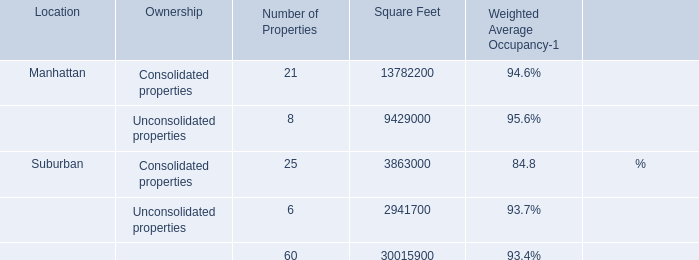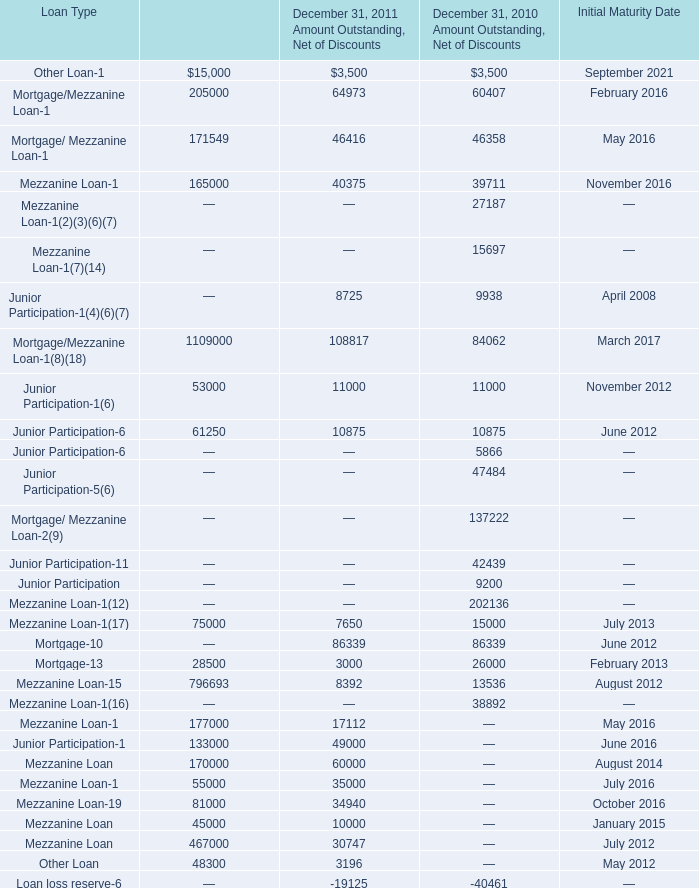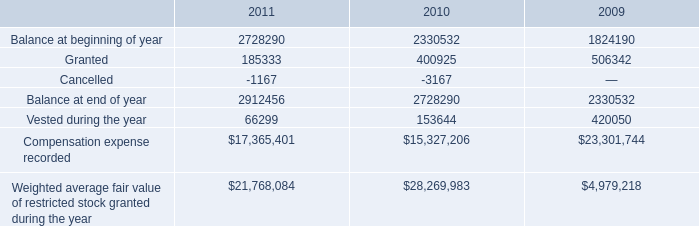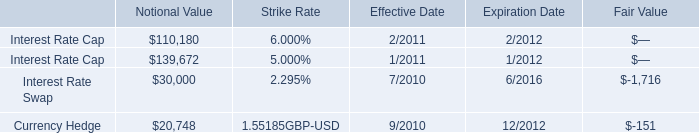what's the total amount of Suburban of Square Feet, Junior Participation of December 31, 2011 Senior Financing, and total of Square Feet ? 
Computations: ((3863000.0 + 133000.0) + 9429000.0)
Answer: 13425000.0. 